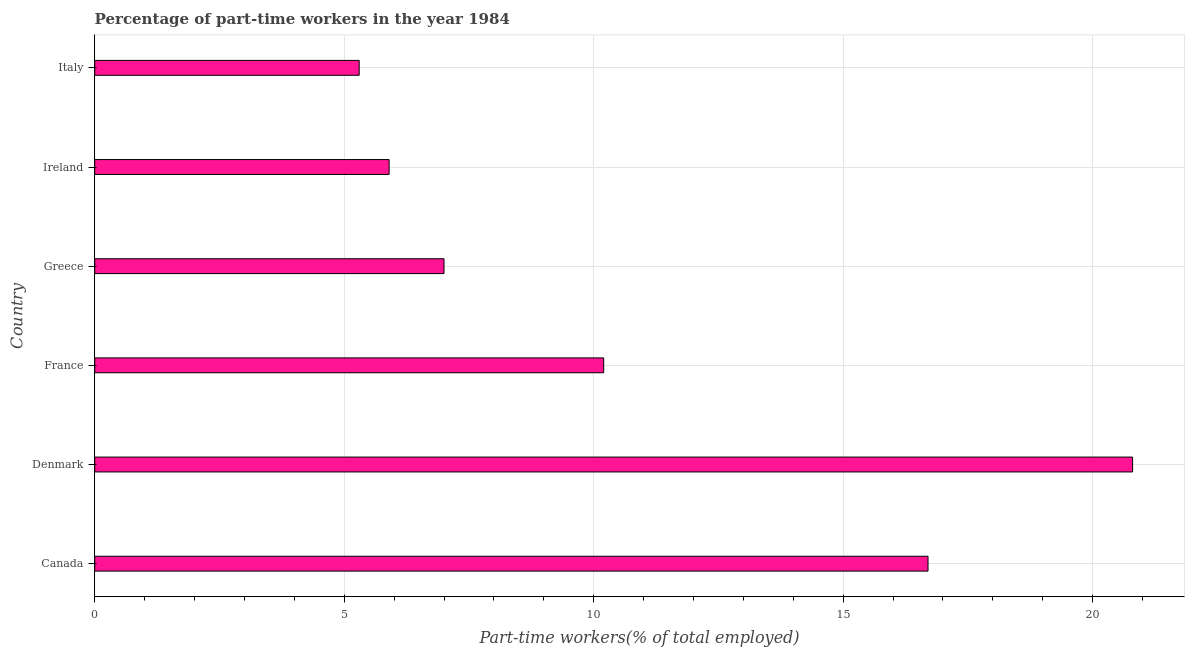Does the graph contain any zero values?
Your answer should be very brief. No. What is the title of the graph?
Provide a short and direct response. Percentage of part-time workers in the year 1984. What is the label or title of the X-axis?
Offer a very short reply. Part-time workers(% of total employed). What is the label or title of the Y-axis?
Your answer should be compact. Country. What is the percentage of part-time workers in France?
Give a very brief answer. 10.2. Across all countries, what is the maximum percentage of part-time workers?
Offer a terse response. 20.8. Across all countries, what is the minimum percentage of part-time workers?
Your response must be concise. 5.3. In which country was the percentage of part-time workers maximum?
Make the answer very short. Denmark. In which country was the percentage of part-time workers minimum?
Offer a very short reply. Italy. What is the sum of the percentage of part-time workers?
Give a very brief answer. 65.9. What is the difference between the percentage of part-time workers in Canada and France?
Give a very brief answer. 6.5. What is the average percentage of part-time workers per country?
Offer a terse response. 10.98. What is the median percentage of part-time workers?
Provide a succinct answer. 8.6. In how many countries, is the percentage of part-time workers greater than 3 %?
Provide a short and direct response. 6. What is the ratio of the percentage of part-time workers in Denmark to that in Greece?
Your answer should be compact. 2.97. Is the difference between the percentage of part-time workers in Denmark and Italy greater than the difference between any two countries?
Offer a terse response. Yes. How many bars are there?
Provide a short and direct response. 6. Are all the bars in the graph horizontal?
Provide a short and direct response. Yes. How many countries are there in the graph?
Keep it short and to the point. 6. What is the Part-time workers(% of total employed) in Canada?
Give a very brief answer. 16.7. What is the Part-time workers(% of total employed) of Denmark?
Your answer should be very brief. 20.8. What is the Part-time workers(% of total employed) of France?
Your answer should be very brief. 10.2. What is the Part-time workers(% of total employed) in Ireland?
Ensure brevity in your answer.  5.9. What is the Part-time workers(% of total employed) of Italy?
Offer a very short reply. 5.3. What is the difference between the Part-time workers(% of total employed) in Canada and Denmark?
Your response must be concise. -4.1. What is the difference between the Part-time workers(% of total employed) in Canada and France?
Keep it short and to the point. 6.5. What is the difference between the Part-time workers(% of total employed) in Canada and Greece?
Provide a succinct answer. 9.7. What is the difference between the Part-time workers(% of total employed) in Canada and Ireland?
Your answer should be compact. 10.8. What is the difference between the Part-time workers(% of total employed) in Denmark and Greece?
Ensure brevity in your answer.  13.8. What is the difference between the Part-time workers(% of total employed) in Denmark and Ireland?
Your response must be concise. 14.9. What is the ratio of the Part-time workers(% of total employed) in Canada to that in Denmark?
Keep it short and to the point. 0.8. What is the ratio of the Part-time workers(% of total employed) in Canada to that in France?
Offer a terse response. 1.64. What is the ratio of the Part-time workers(% of total employed) in Canada to that in Greece?
Give a very brief answer. 2.39. What is the ratio of the Part-time workers(% of total employed) in Canada to that in Ireland?
Provide a succinct answer. 2.83. What is the ratio of the Part-time workers(% of total employed) in Canada to that in Italy?
Offer a terse response. 3.15. What is the ratio of the Part-time workers(% of total employed) in Denmark to that in France?
Make the answer very short. 2.04. What is the ratio of the Part-time workers(% of total employed) in Denmark to that in Greece?
Offer a very short reply. 2.97. What is the ratio of the Part-time workers(% of total employed) in Denmark to that in Ireland?
Ensure brevity in your answer.  3.52. What is the ratio of the Part-time workers(% of total employed) in Denmark to that in Italy?
Keep it short and to the point. 3.92. What is the ratio of the Part-time workers(% of total employed) in France to that in Greece?
Ensure brevity in your answer.  1.46. What is the ratio of the Part-time workers(% of total employed) in France to that in Ireland?
Keep it short and to the point. 1.73. What is the ratio of the Part-time workers(% of total employed) in France to that in Italy?
Your answer should be very brief. 1.93. What is the ratio of the Part-time workers(% of total employed) in Greece to that in Ireland?
Keep it short and to the point. 1.19. What is the ratio of the Part-time workers(% of total employed) in Greece to that in Italy?
Your answer should be compact. 1.32. What is the ratio of the Part-time workers(% of total employed) in Ireland to that in Italy?
Ensure brevity in your answer.  1.11. 